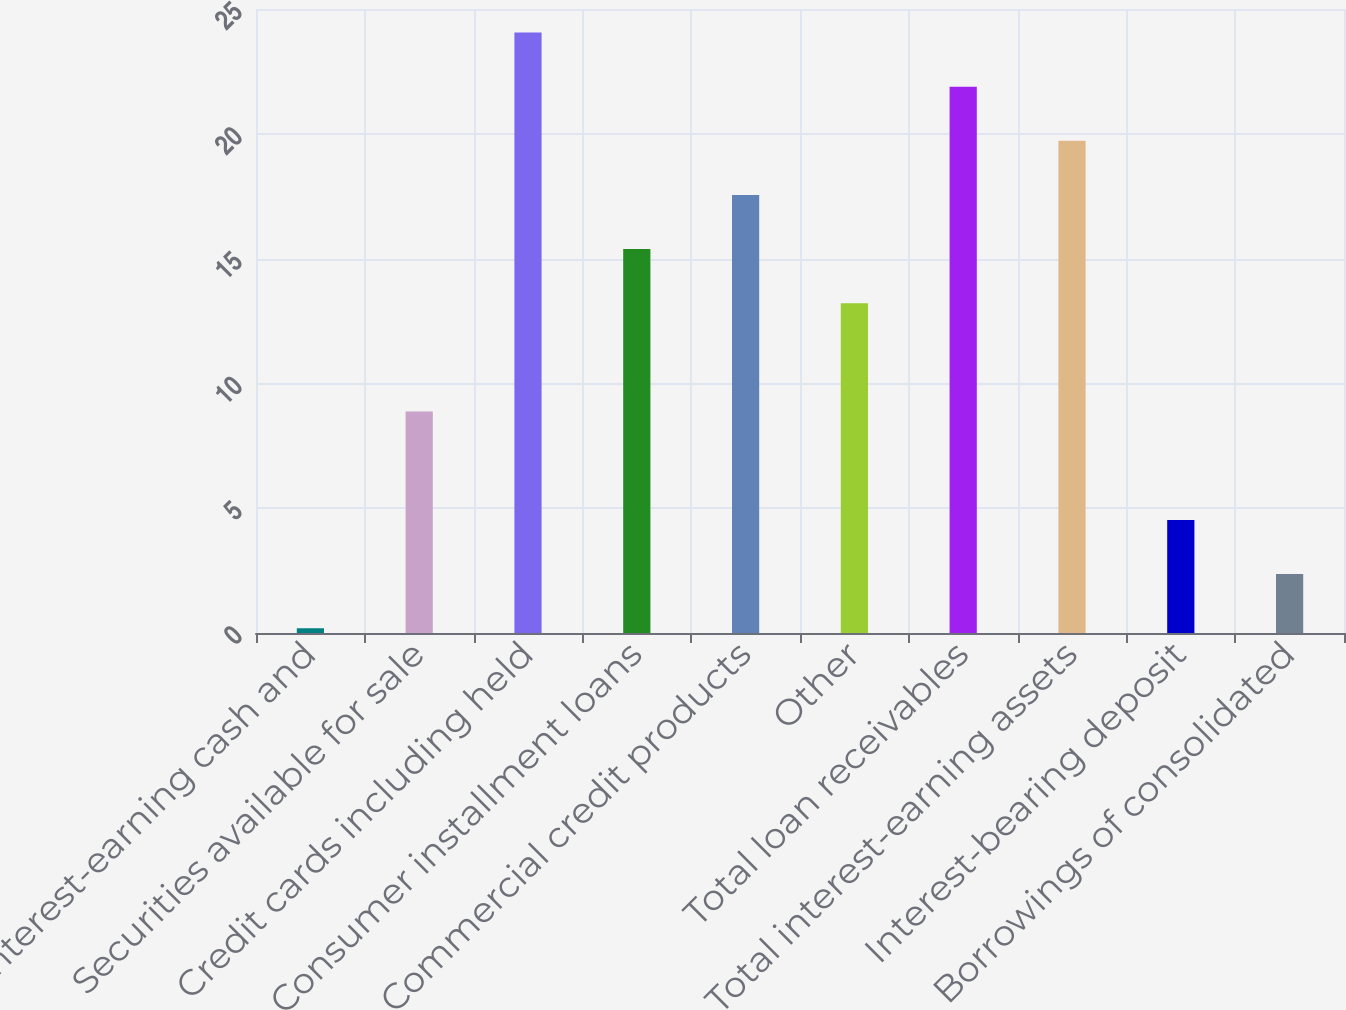Convert chart. <chart><loc_0><loc_0><loc_500><loc_500><bar_chart><fcel>Interest-earning cash and<fcel>Securities available for sale<fcel>Credit cards including held<fcel>Consumer installment loans<fcel>Commercial credit products<fcel>Other<fcel>Total loan receivables<fcel>Total interest-earning assets<fcel>Interest-bearing deposit<fcel>Borrowings of consolidated<nl><fcel>0.19<fcel>8.87<fcel>24.06<fcel>15.38<fcel>17.55<fcel>13.21<fcel>21.89<fcel>19.72<fcel>4.53<fcel>2.36<nl></chart> 